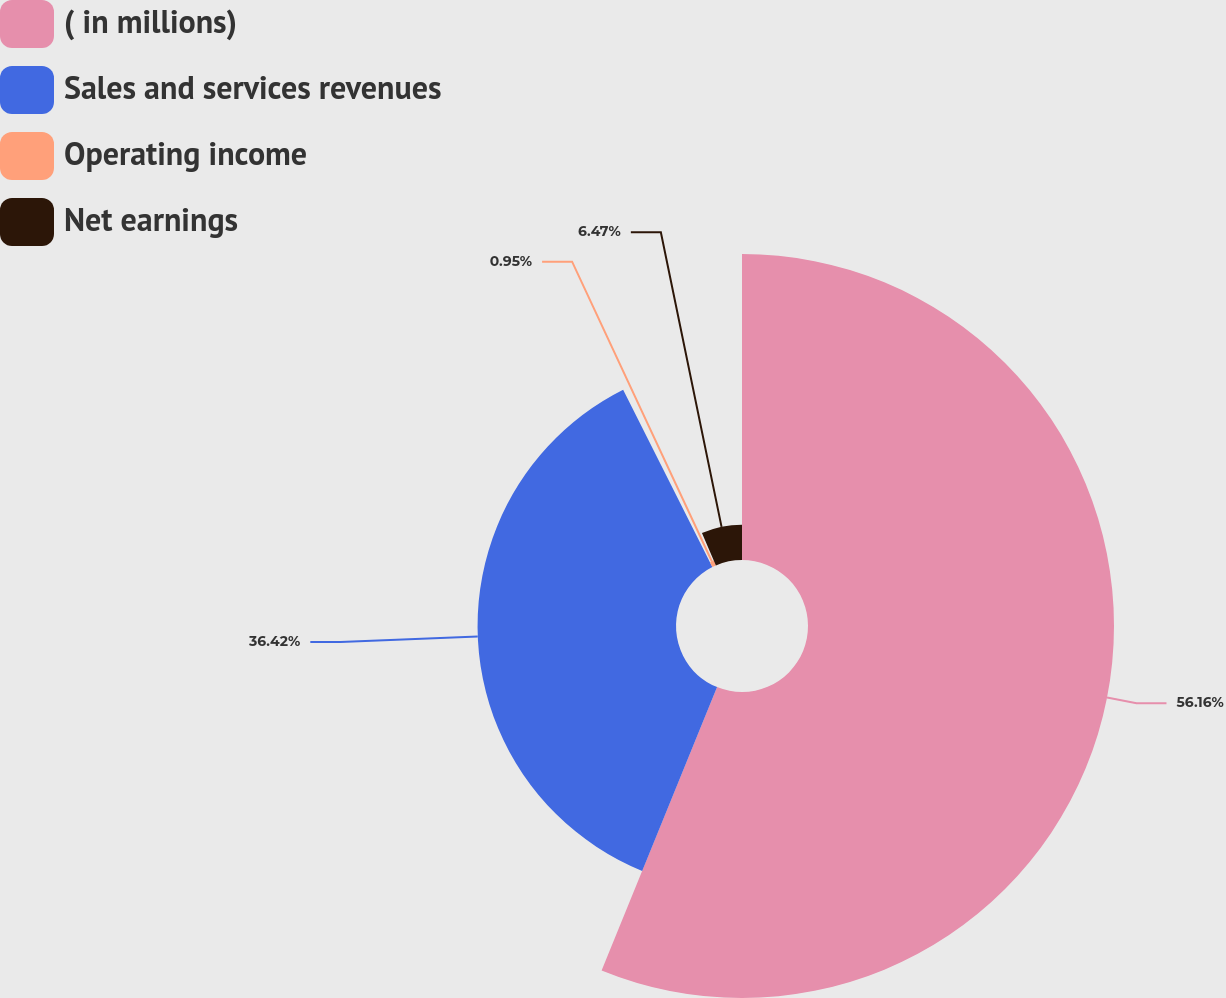Convert chart. <chart><loc_0><loc_0><loc_500><loc_500><pie_chart><fcel>( in millions)<fcel>Sales and services revenues<fcel>Operating income<fcel>Net earnings<nl><fcel>56.16%<fcel>36.42%<fcel>0.95%<fcel>6.47%<nl></chart> 